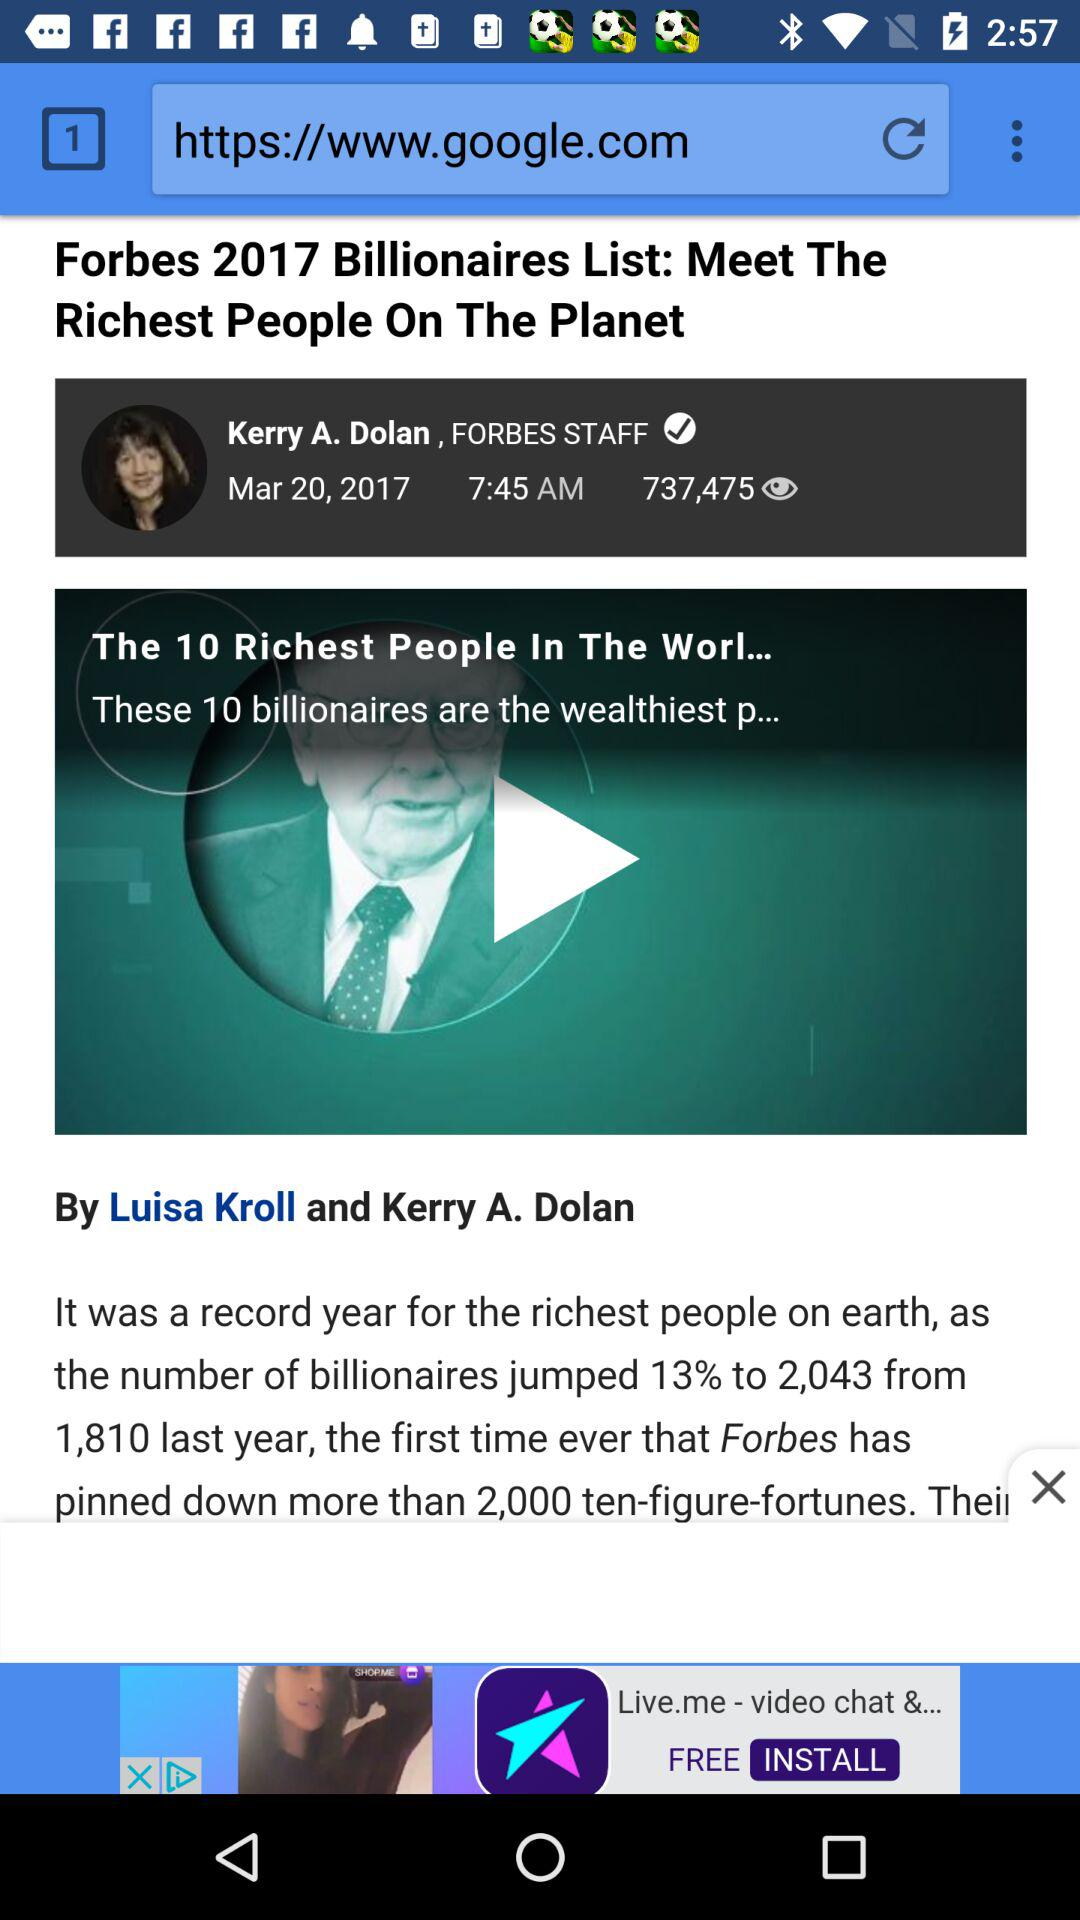How many people viewed the news? The news was viewed by 737,475 people. 